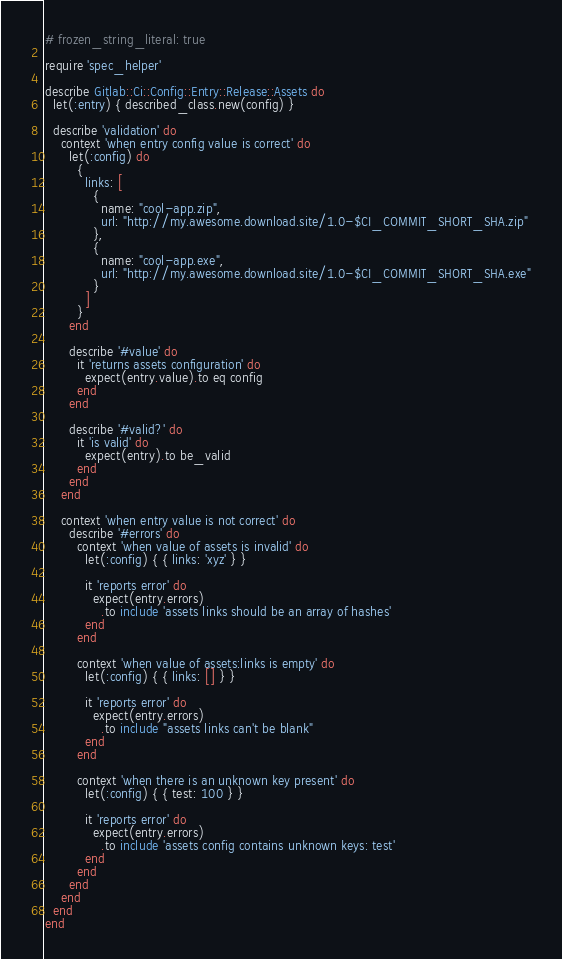Convert code to text. <code><loc_0><loc_0><loc_500><loc_500><_Ruby_># frozen_string_literal: true

require 'spec_helper'

describe Gitlab::Ci::Config::Entry::Release::Assets do
  let(:entry) { described_class.new(config) }

  describe 'validation' do
    context 'when entry config value is correct' do
      let(:config) do
        {
          links: [
            {
              name: "cool-app.zip",
              url: "http://my.awesome.download.site/1.0-$CI_COMMIT_SHORT_SHA.zip"
            },
            {
              name: "cool-app.exe",
              url: "http://my.awesome.download.site/1.0-$CI_COMMIT_SHORT_SHA.exe"
            }
          ]
        }
      end

      describe '#value' do
        it 'returns assets configuration' do
          expect(entry.value).to eq config
        end
      end

      describe '#valid?' do
        it 'is valid' do
          expect(entry).to be_valid
        end
      end
    end

    context 'when entry value is not correct' do
      describe '#errors' do
        context 'when value of assets is invalid' do
          let(:config) { { links: 'xyz' } }

          it 'reports error' do
            expect(entry.errors)
              .to include 'assets links should be an array of hashes'
          end
        end

        context 'when value of assets:links is empty' do
          let(:config) { { links: [] } }

          it 'reports error' do
            expect(entry.errors)
              .to include "assets links can't be blank"
          end
        end

        context 'when there is an unknown key present' do
          let(:config) { { test: 100 } }

          it 'reports error' do
            expect(entry.errors)
              .to include 'assets config contains unknown keys: test'
          end
        end
      end
    end
  end
end
</code> 